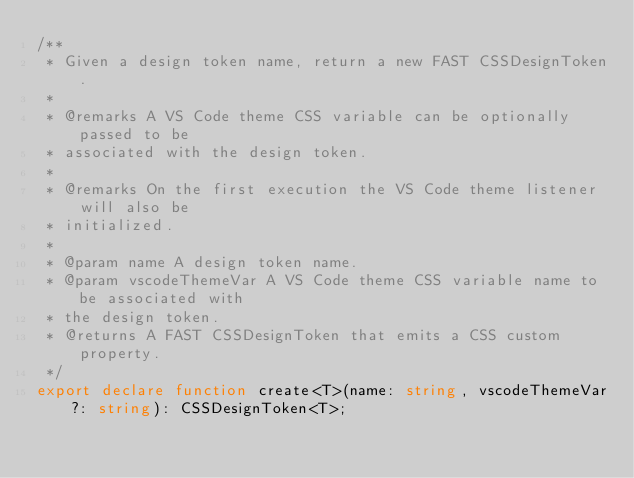Convert code to text. <code><loc_0><loc_0><loc_500><loc_500><_TypeScript_>/**
 * Given a design token name, return a new FAST CSSDesignToken.
 *
 * @remarks A VS Code theme CSS variable can be optionally passed to be
 * associated with the design token.
 *
 * @remarks On the first execution the VS Code theme listener will also be
 * initialized.
 *
 * @param name A design token name.
 * @param vscodeThemeVar A VS Code theme CSS variable name to be associated with
 * the design token.
 * @returns A FAST CSSDesignToken that emits a CSS custom property.
 */
export declare function create<T>(name: string, vscodeThemeVar?: string): CSSDesignToken<T>;
</code> 